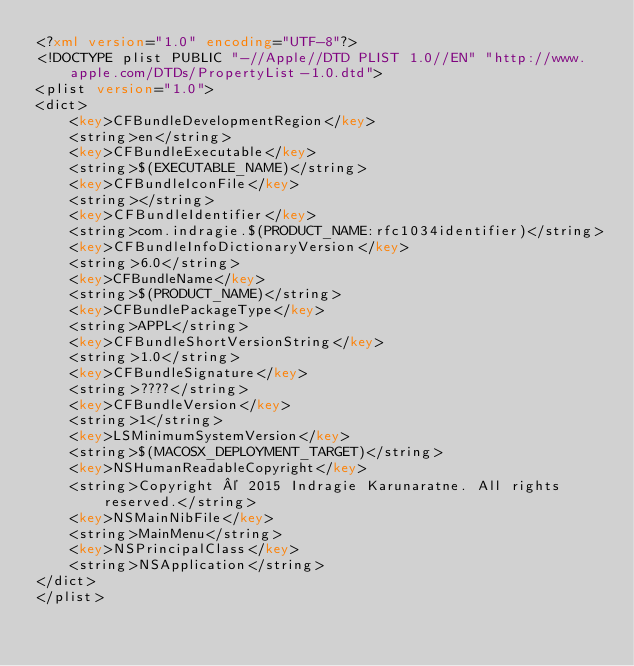<code> <loc_0><loc_0><loc_500><loc_500><_XML_><?xml version="1.0" encoding="UTF-8"?>
<!DOCTYPE plist PUBLIC "-//Apple//DTD PLIST 1.0//EN" "http://www.apple.com/DTDs/PropertyList-1.0.dtd">
<plist version="1.0">
<dict>
	<key>CFBundleDevelopmentRegion</key>
	<string>en</string>
	<key>CFBundleExecutable</key>
	<string>$(EXECUTABLE_NAME)</string>
	<key>CFBundleIconFile</key>
	<string></string>
	<key>CFBundleIdentifier</key>
	<string>com.indragie.$(PRODUCT_NAME:rfc1034identifier)</string>
	<key>CFBundleInfoDictionaryVersion</key>
	<string>6.0</string>
	<key>CFBundleName</key>
	<string>$(PRODUCT_NAME)</string>
	<key>CFBundlePackageType</key>
	<string>APPL</string>
	<key>CFBundleShortVersionString</key>
	<string>1.0</string>
	<key>CFBundleSignature</key>
	<string>????</string>
	<key>CFBundleVersion</key>
	<string>1</string>
	<key>LSMinimumSystemVersion</key>
	<string>$(MACOSX_DEPLOYMENT_TARGET)</string>
	<key>NSHumanReadableCopyright</key>
	<string>Copyright © 2015 Indragie Karunaratne. All rights reserved.</string>
	<key>NSMainNibFile</key>
	<string>MainMenu</string>
	<key>NSPrincipalClass</key>
	<string>NSApplication</string>
</dict>
</plist>
</code> 